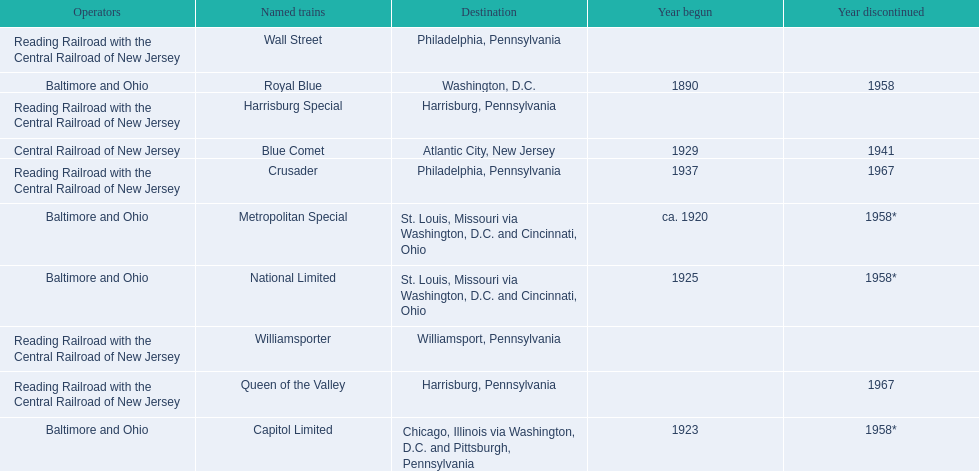What were all of the destinations? Chicago, Illinois via Washington, D.C. and Pittsburgh, Pennsylvania, St. Louis, Missouri via Washington, D.C. and Cincinnati, Ohio, St. Louis, Missouri via Washington, D.C. and Cincinnati, Ohio, Washington, D.C., Atlantic City, New Jersey, Philadelphia, Pennsylvania, Harrisburg, Pennsylvania, Harrisburg, Pennsylvania, Philadelphia, Pennsylvania, Williamsport, Pennsylvania. And what were the names of the trains? Capitol Limited, Metropolitan Special, National Limited, Royal Blue, Blue Comet, Crusader, Harrisburg Special, Queen of the Valley, Wall Street, Williamsporter. Of those, and along with wall street, which train ran to philadelphia, pennsylvania? Crusader. 